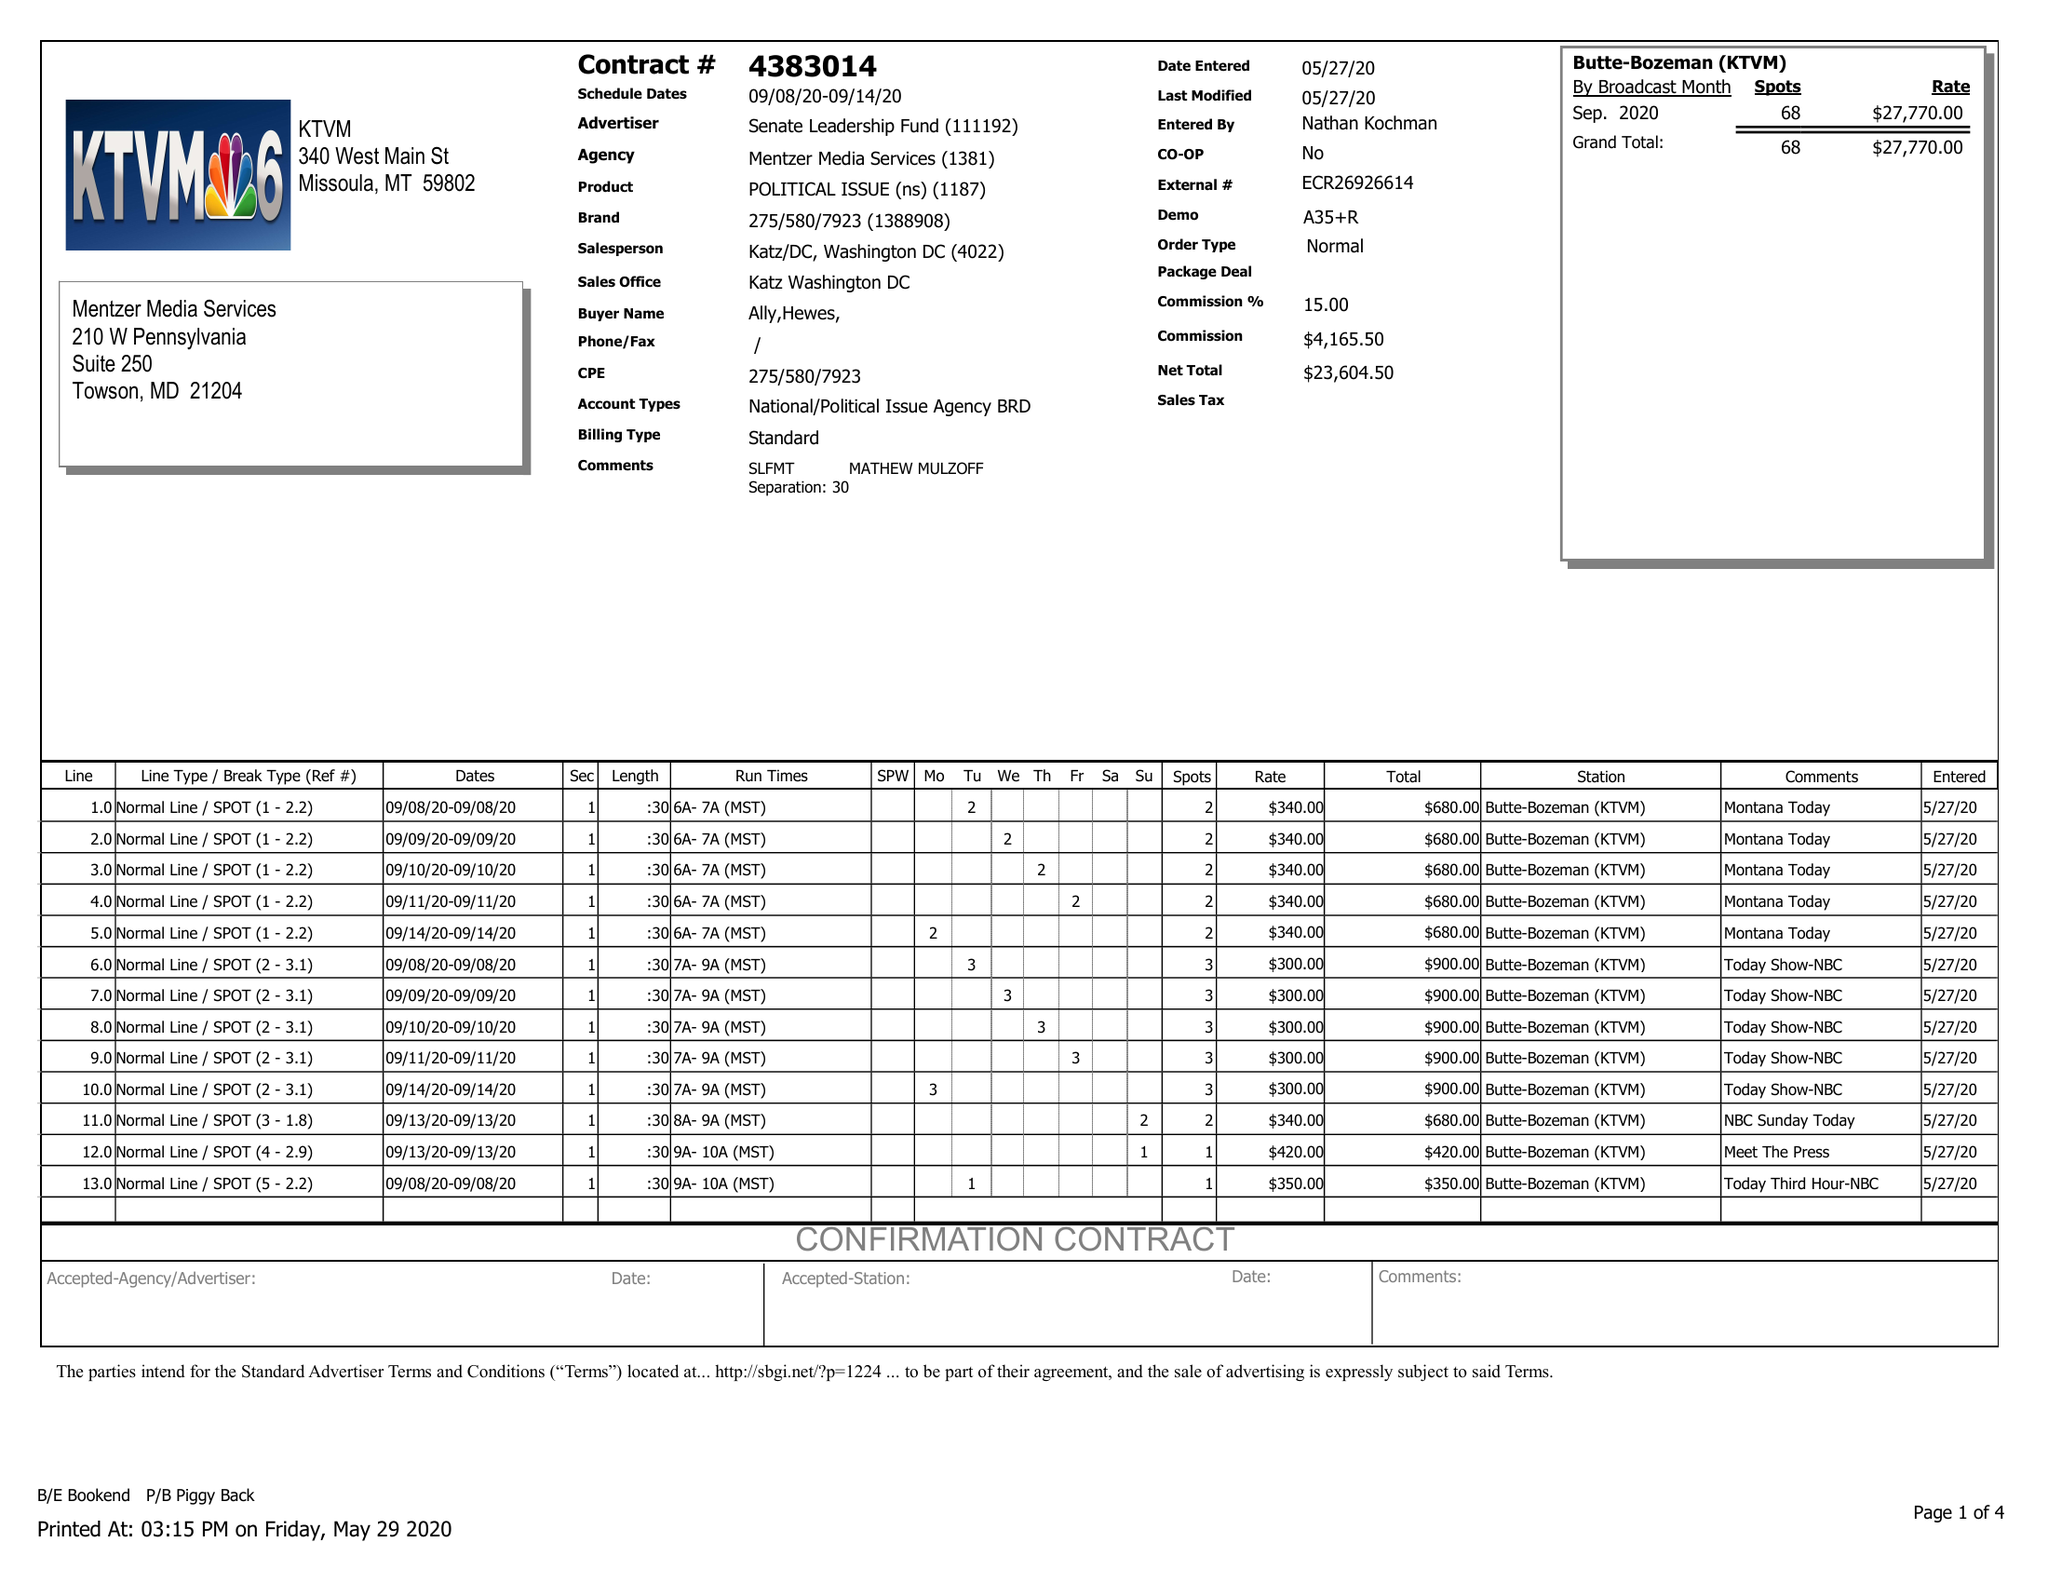What is the value for the flight_to?
Answer the question using a single word or phrase. 09/14/20 